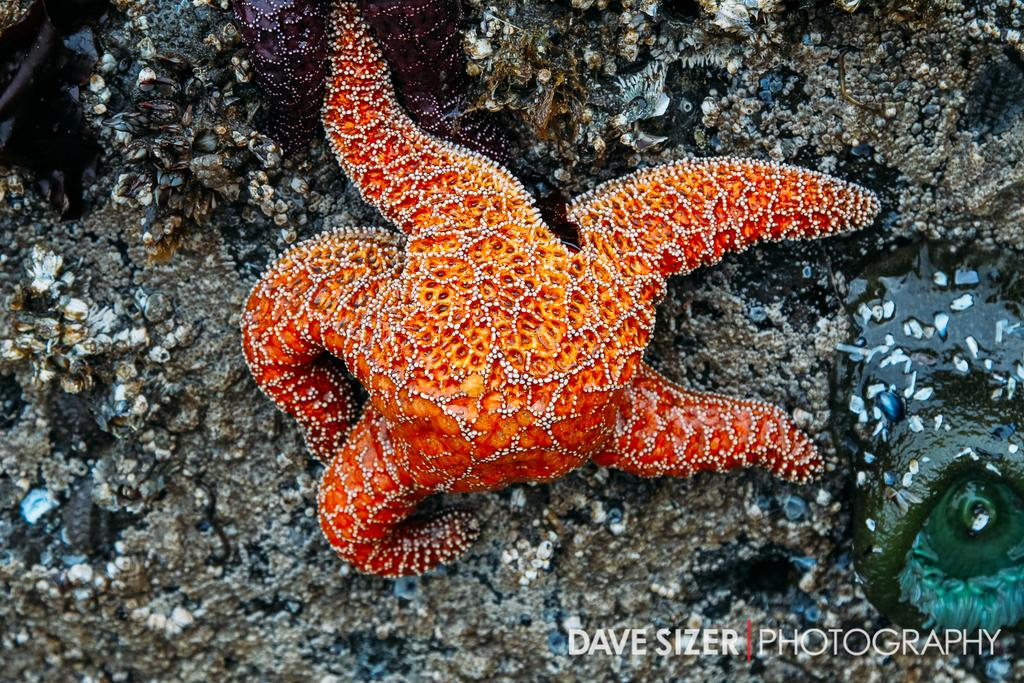What marine animal can be seen on the seabed in the image? There is a starfish on the seabed in the image. What else is present in the image besides the starfish? There is some text at the bottom of the image. What type of wall can be seen in the image? There is no wall present in the image; it features a starfish on the seabed and some text at the bottom. 